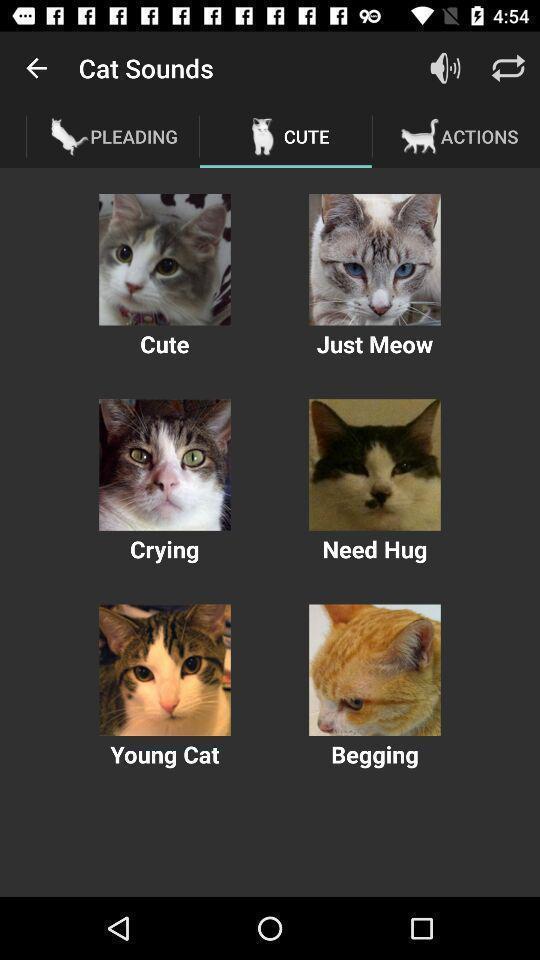Please provide a description for this image. Screen displaying various cat images. 